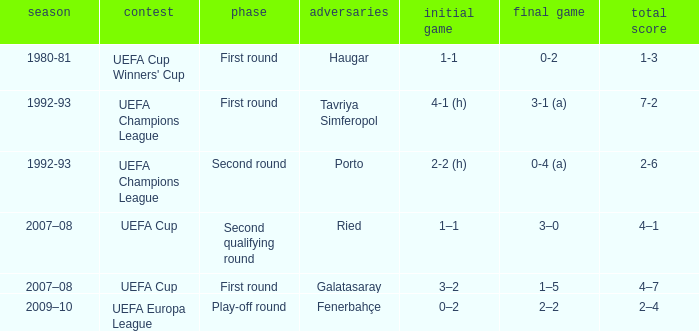What is the total number of round where opponents is haugar 1.0. 